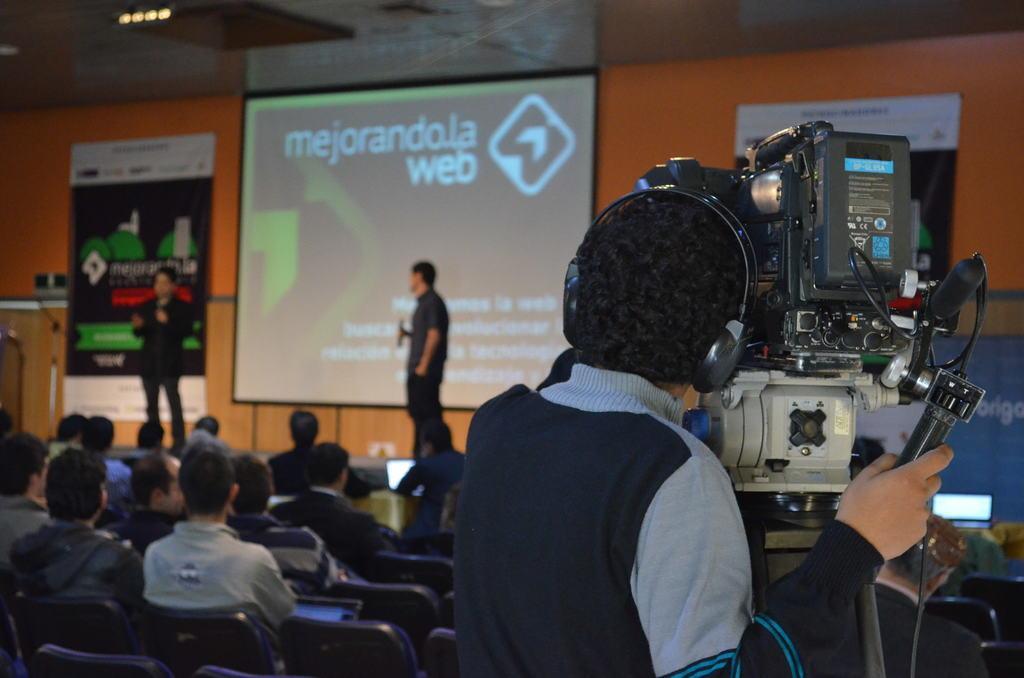Can you describe this image briefly? In this picture there are group of people sitting on the chairs. At the back there are two persons standing on the stage. There is a text on the screen and there is a hoarding. On the right side of the image there is a person standing and holding the camera. At the top there are lights. 